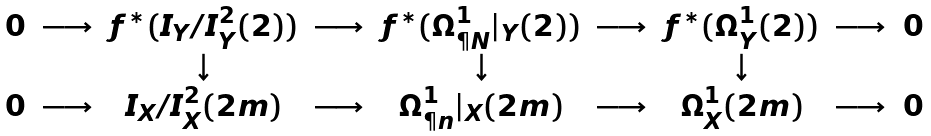Convert formula to latex. <formula><loc_0><loc_0><loc_500><loc_500>\begin{array} { c c c c c c c c c } 0 & \longrightarrow & f ^ { * } ( I _ { Y } / I _ { Y } ^ { 2 } ( 2 ) ) & \longrightarrow & f ^ { * } ( \Omega ^ { 1 } _ { \P N } | _ { Y } ( 2 ) ) & \longrightarrow & f ^ { * } ( \Omega ^ { 1 } _ { Y } ( 2 ) ) & \longrightarrow & 0 \\ & & \downarrow & & \downarrow & & \downarrow & & \\ 0 & \longrightarrow & I _ { X } / I _ { X } ^ { 2 } ( 2 m ) & \longrightarrow & \Omega ^ { 1 } _ { \P n } | _ { X } ( 2 m ) & \longrightarrow & \Omega ^ { 1 } _ { X } ( 2 m ) & \longrightarrow & 0 \end{array}</formula> 